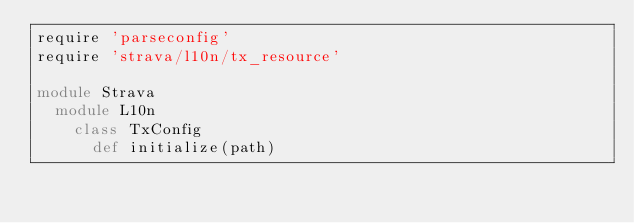Convert code to text. <code><loc_0><loc_0><loc_500><loc_500><_Ruby_>require 'parseconfig'
require 'strava/l10n/tx_resource'

module Strava
  module L10n
    class TxConfig
      def initialize(path)</code> 